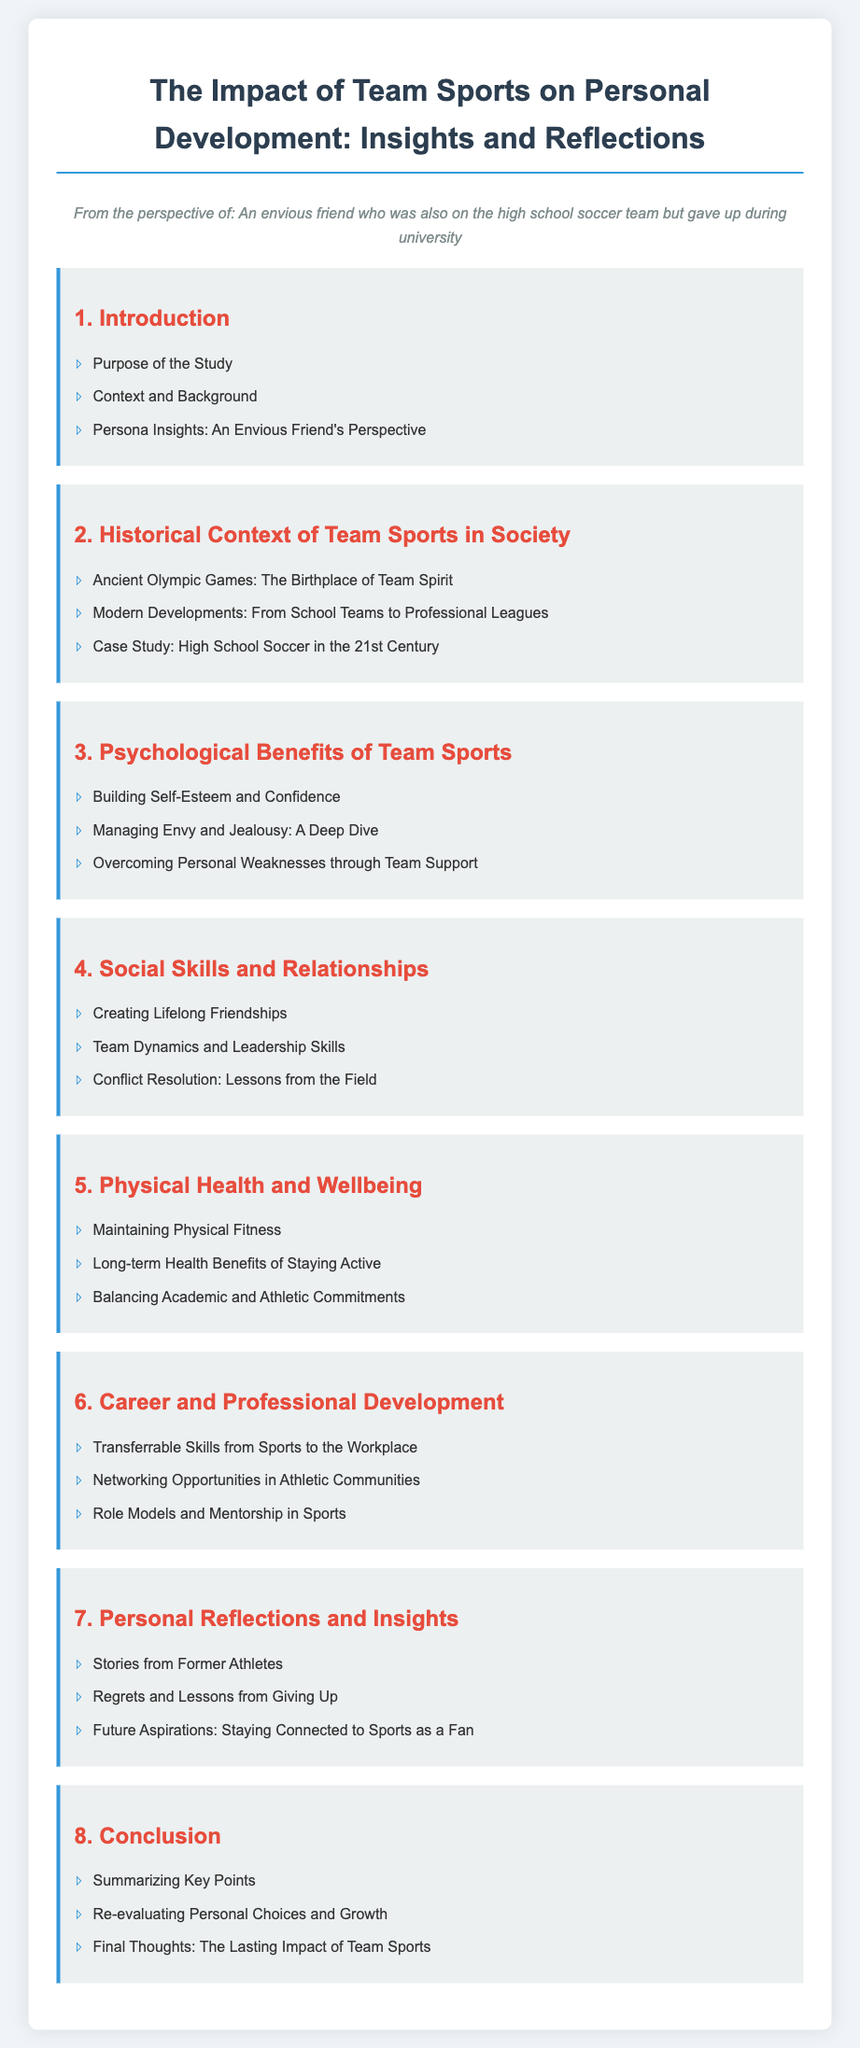what is the title of the document? The title of the document is the main heading at the top of the content, summarizing the focus of the study.
Answer: The Impact of Team Sports on Personal Development: Insights and Reflections how many sections are included in the document? There are a total of 8 numbered sections outlined in the table of contents.
Answer: 8 what psychological benefit is specifically mentioned in relation to managing emotions? The document highlights "Managing Envy and Jealousy" as a specific psychological benefit.
Answer: Managing Envy and Jealousy what kind of relationships do team sports help to create? The document mentions that team sports are essential for building strong and lasting connections.
Answer: Lifelong Friendships what is one long-term health aspect discussed in relation to team sports? The document emphasizes the importance of long-term health benefits associated with being physically active through sports.
Answer: Long-term Health Benefits of Staying Active which section includes stories from former athletes? The section that shares personal experiences from previous participants in sports is within Personal Reflections and Insights.
Answer: Personal Reflections and Insights what is the focus of the section on Career and Professional Development? This section explores how skills gained in sports can enhance career opportunities and professional growth.
Answer: Transferrable Skills from Sports to the Workplace what is the aim stated in the Introduction section? The purpose or intent behind conducting the study is outlined in the Introduction section.
Answer: Purpose of the Study 